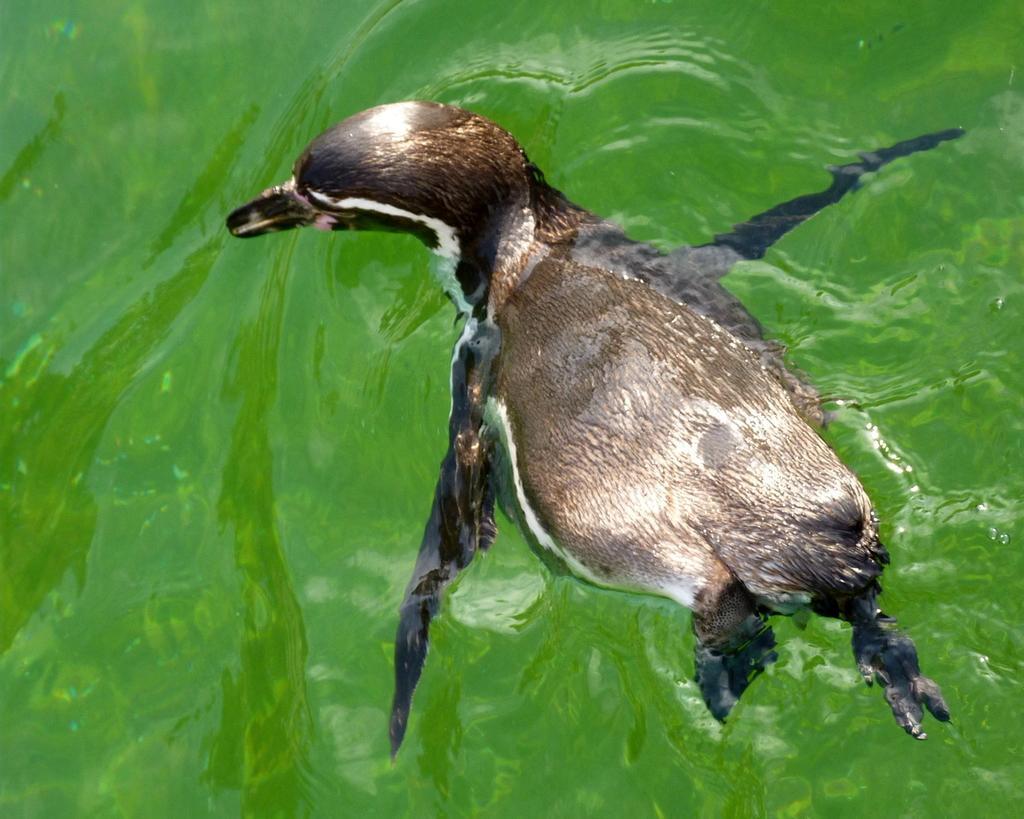Please provide a concise description of this image. In the image we can see an animal, in the water. The animal is black and brown in color. 